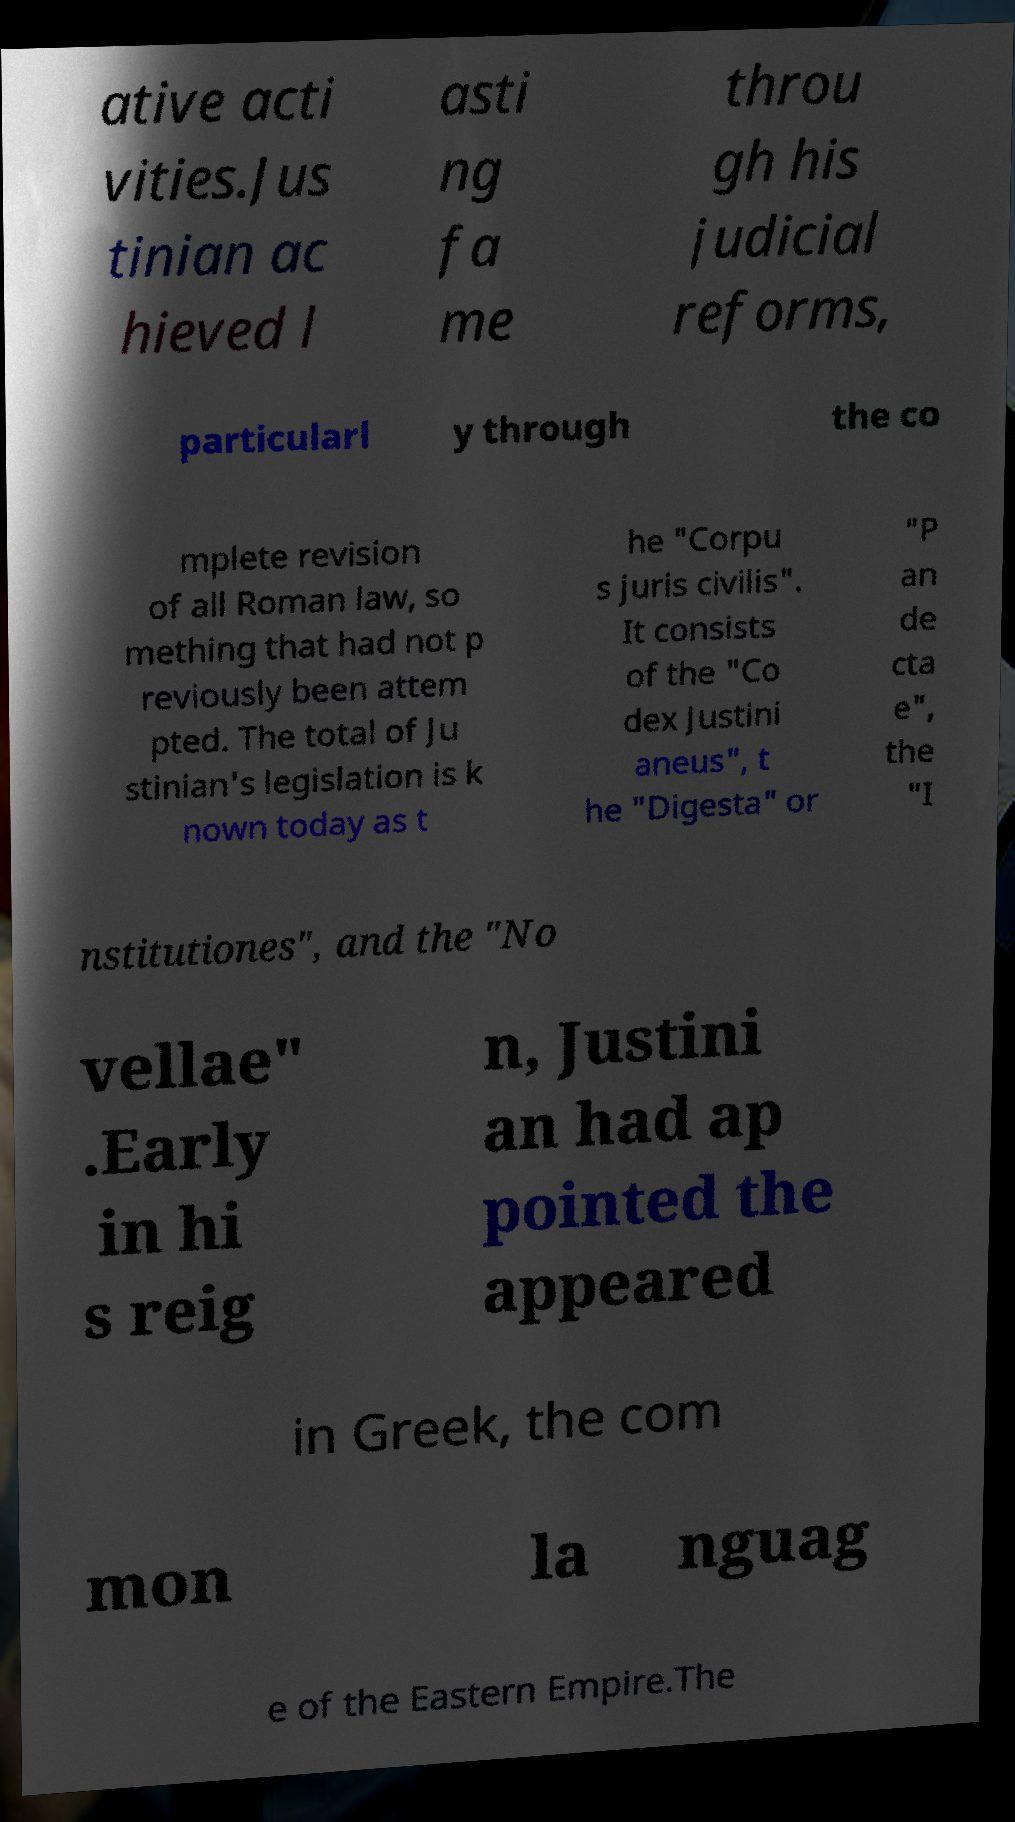Could you assist in decoding the text presented in this image and type it out clearly? ative acti vities.Jus tinian ac hieved l asti ng fa me throu gh his judicial reforms, particularl y through the co mplete revision of all Roman law, so mething that had not p reviously been attem pted. The total of Ju stinian's legislation is k nown today as t he "Corpu s juris civilis". It consists of the "Co dex Justini aneus", t he "Digesta" or "P an de cta e", the "I nstitutiones", and the "No vellae" .Early in hi s reig n, Justini an had ap pointed the appeared in Greek, the com mon la nguag e of the Eastern Empire.The 